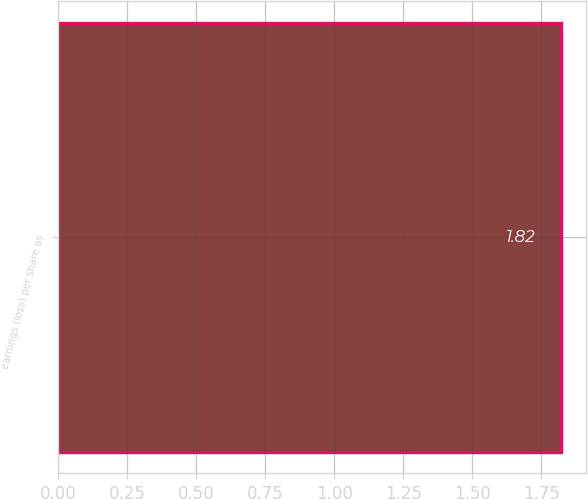Convert chart. <chart><loc_0><loc_0><loc_500><loc_500><bar_chart><fcel>earnings (loss) per share as<nl><fcel>1.82<nl></chart> 